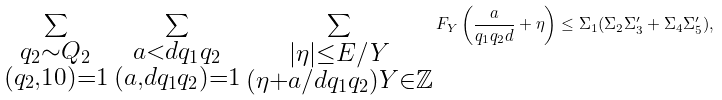<formula> <loc_0><loc_0><loc_500><loc_500>\sum _ { \substack { q _ { 2 } \sim Q _ { 2 } \\ ( q _ { 2 } , 1 0 ) = 1 } } \, \sum _ { \substack { a < d q _ { 1 } q _ { 2 } \\ ( a , d q _ { 1 } q _ { 2 } ) = 1 } } \, \sum _ { \substack { | \eta | \leq E / Y \\ ( \eta + a / d q _ { 1 } q _ { 2 } ) Y \in \mathbb { Z } } } F _ { Y } \left ( \frac { a } { q _ { 1 } q _ { 2 } d } + \eta \right ) \leq \Sigma _ { 1 } ( \Sigma _ { 2 } \Sigma _ { 3 } ^ { \prime } + \Sigma _ { 4 } \Sigma _ { 5 } ^ { \prime } ) ,</formula> 